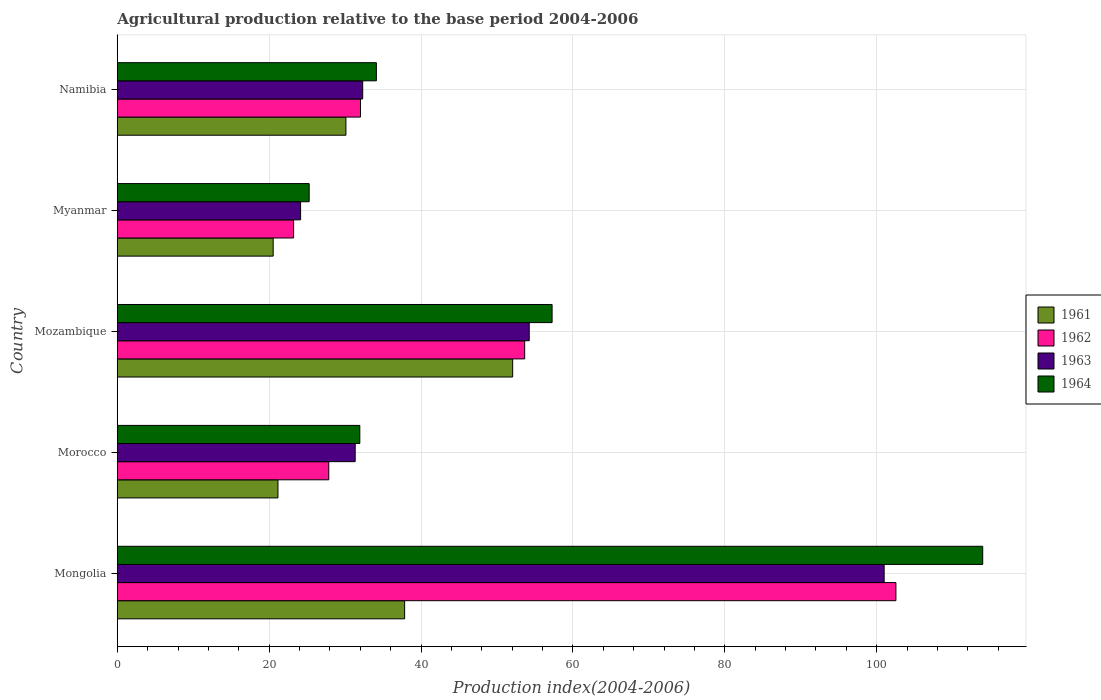How many groups of bars are there?
Offer a very short reply. 5. Are the number of bars per tick equal to the number of legend labels?
Offer a terse response. Yes. Are the number of bars on each tick of the Y-axis equal?
Offer a very short reply. Yes. How many bars are there on the 4th tick from the bottom?
Provide a short and direct response. 4. What is the label of the 3rd group of bars from the top?
Offer a terse response. Mozambique. In how many cases, is the number of bars for a given country not equal to the number of legend labels?
Provide a short and direct response. 0. What is the agricultural production index in 1962 in Morocco?
Ensure brevity in your answer.  27.85. Across all countries, what is the maximum agricultural production index in 1961?
Provide a short and direct response. 52.07. Across all countries, what is the minimum agricultural production index in 1962?
Ensure brevity in your answer.  23.22. In which country was the agricultural production index in 1963 maximum?
Provide a succinct answer. Mongolia. In which country was the agricultural production index in 1964 minimum?
Your response must be concise. Myanmar. What is the total agricultural production index in 1961 in the graph?
Give a very brief answer. 161.71. What is the difference between the agricultural production index in 1963 in Mongolia and that in Namibia?
Ensure brevity in your answer.  68.67. What is the difference between the agricultural production index in 1962 in Mozambique and the agricultural production index in 1964 in Morocco?
Your answer should be very brief. 21.71. What is the average agricultural production index in 1962 per country?
Your answer should be very brief. 47.86. What is the difference between the agricultural production index in 1962 and agricultural production index in 1964 in Mongolia?
Your answer should be compact. -11.43. In how many countries, is the agricultural production index in 1962 greater than 104 ?
Offer a very short reply. 0. What is the ratio of the agricultural production index in 1964 in Morocco to that in Myanmar?
Give a very brief answer. 1.26. Is the difference between the agricultural production index in 1962 in Mongolia and Myanmar greater than the difference between the agricultural production index in 1964 in Mongolia and Myanmar?
Make the answer very short. No. What is the difference between the highest and the second highest agricultural production index in 1964?
Your answer should be very brief. 56.71. What is the difference between the highest and the lowest agricultural production index in 1964?
Provide a short and direct response. 88.7. Is it the case that in every country, the sum of the agricultural production index in 1964 and agricultural production index in 1962 is greater than the sum of agricultural production index in 1961 and agricultural production index in 1963?
Your response must be concise. No. What does the 1st bar from the top in Myanmar represents?
Ensure brevity in your answer.  1964. What does the 3rd bar from the bottom in Mozambique represents?
Offer a very short reply. 1963. Is it the case that in every country, the sum of the agricultural production index in 1963 and agricultural production index in 1961 is greater than the agricultural production index in 1964?
Give a very brief answer. Yes. Are the values on the major ticks of X-axis written in scientific E-notation?
Provide a succinct answer. No. Does the graph contain grids?
Your answer should be compact. Yes. Where does the legend appear in the graph?
Provide a short and direct response. Center right. How are the legend labels stacked?
Your response must be concise. Vertical. What is the title of the graph?
Make the answer very short. Agricultural production relative to the base period 2004-2006. Does "2006" appear as one of the legend labels in the graph?
Give a very brief answer. No. What is the label or title of the X-axis?
Offer a terse response. Production index(2004-2006). What is the label or title of the Y-axis?
Make the answer very short. Country. What is the Production index(2004-2006) of 1961 in Mongolia?
Ensure brevity in your answer.  37.84. What is the Production index(2004-2006) of 1962 in Mongolia?
Ensure brevity in your answer.  102.54. What is the Production index(2004-2006) of 1963 in Mongolia?
Offer a terse response. 100.99. What is the Production index(2004-2006) in 1964 in Mongolia?
Your response must be concise. 113.97. What is the Production index(2004-2006) of 1961 in Morocco?
Make the answer very short. 21.16. What is the Production index(2004-2006) in 1962 in Morocco?
Your response must be concise. 27.85. What is the Production index(2004-2006) in 1963 in Morocco?
Make the answer very short. 31.33. What is the Production index(2004-2006) in 1964 in Morocco?
Make the answer very short. 31.94. What is the Production index(2004-2006) in 1961 in Mozambique?
Offer a terse response. 52.07. What is the Production index(2004-2006) in 1962 in Mozambique?
Your response must be concise. 53.65. What is the Production index(2004-2006) of 1963 in Mozambique?
Your answer should be compact. 54.25. What is the Production index(2004-2006) of 1964 in Mozambique?
Your answer should be compact. 57.26. What is the Production index(2004-2006) of 1961 in Myanmar?
Ensure brevity in your answer.  20.53. What is the Production index(2004-2006) in 1962 in Myanmar?
Ensure brevity in your answer.  23.22. What is the Production index(2004-2006) in 1963 in Myanmar?
Offer a terse response. 24.14. What is the Production index(2004-2006) in 1964 in Myanmar?
Keep it short and to the point. 25.27. What is the Production index(2004-2006) in 1961 in Namibia?
Your response must be concise. 30.11. What is the Production index(2004-2006) of 1962 in Namibia?
Give a very brief answer. 32.03. What is the Production index(2004-2006) of 1963 in Namibia?
Your response must be concise. 32.32. What is the Production index(2004-2006) of 1964 in Namibia?
Your answer should be very brief. 34.12. Across all countries, what is the maximum Production index(2004-2006) in 1961?
Your response must be concise. 52.07. Across all countries, what is the maximum Production index(2004-2006) in 1962?
Provide a succinct answer. 102.54. Across all countries, what is the maximum Production index(2004-2006) in 1963?
Ensure brevity in your answer.  100.99. Across all countries, what is the maximum Production index(2004-2006) of 1964?
Provide a succinct answer. 113.97. Across all countries, what is the minimum Production index(2004-2006) of 1961?
Offer a terse response. 20.53. Across all countries, what is the minimum Production index(2004-2006) in 1962?
Keep it short and to the point. 23.22. Across all countries, what is the minimum Production index(2004-2006) of 1963?
Offer a terse response. 24.14. Across all countries, what is the minimum Production index(2004-2006) in 1964?
Keep it short and to the point. 25.27. What is the total Production index(2004-2006) of 1961 in the graph?
Your answer should be compact. 161.71. What is the total Production index(2004-2006) in 1962 in the graph?
Provide a short and direct response. 239.29. What is the total Production index(2004-2006) in 1963 in the graph?
Keep it short and to the point. 243.03. What is the total Production index(2004-2006) in 1964 in the graph?
Provide a short and direct response. 262.56. What is the difference between the Production index(2004-2006) of 1961 in Mongolia and that in Morocco?
Offer a terse response. 16.68. What is the difference between the Production index(2004-2006) of 1962 in Mongolia and that in Morocco?
Offer a very short reply. 74.69. What is the difference between the Production index(2004-2006) in 1963 in Mongolia and that in Morocco?
Provide a succinct answer. 69.66. What is the difference between the Production index(2004-2006) in 1964 in Mongolia and that in Morocco?
Offer a terse response. 82.03. What is the difference between the Production index(2004-2006) in 1961 in Mongolia and that in Mozambique?
Offer a terse response. -14.23. What is the difference between the Production index(2004-2006) in 1962 in Mongolia and that in Mozambique?
Make the answer very short. 48.89. What is the difference between the Production index(2004-2006) of 1963 in Mongolia and that in Mozambique?
Provide a succinct answer. 46.74. What is the difference between the Production index(2004-2006) of 1964 in Mongolia and that in Mozambique?
Provide a succinct answer. 56.71. What is the difference between the Production index(2004-2006) in 1961 in Mongolia and that in Myanmar?
Give a very brief answer. 17.31. What is the difference between the Production index(2004-2006) of 1962 in Mongolia and that in Myanmar?
Keep it short and to the point. 79.32. What is the difference between the Production index(2004-2006) of 1963 in Mongolia and that in Myanmar?
Your answer should be compact. 76.85. What is the difference between the Production index(2004-2006) of 1964 in Mongolia and that in Myanmar?
Offer a terse response. 88.7. What is the difference between the Production index(2004-2006) of 1961 in Mongolia and that in Namibia?
Give a very brief answer. 7.73. What is the difference between the Production index(2004-2006) in 1962 in Mongolia and that in Namibia?
Your response must be concise. 70.51. What is the difference between the Production index(2004-2006) in 1963 in Mongolia and that in Namibia?
Your answer should be very brief. 68.67. What is the difference between the Production index(2004-2006) of 1964 in Mongolia and that in Namibia?
Make the answer very short. 79.85. What is the difference between the Production index(2004-2006) in 1961 in Morocco and that in Mozambique?
Keep it short and to the point. -30.91. What is the difference between the Production index(2004-2006) of 1962 in Morocco and that in Mozambique?
Offer a very short reply. -25.8. What is the difference between the Production index(2004-2006) of 1963 in Morocco and that in Mozambique?
Give a very brief answer. -22.92. What is the difference between the Production index(2004-2006) of 1964 in Morocco and that in Mozambique?
Your response must be concise. -25.32. What is the difference between the Production index(2004-2006) of 1961 in Morocco and that in Myanmar?
Provide a short and direct response. 0.63. What is the difference between the Production index(2004-2006) of 1962 in Morocco and that in Myanmar?
Provide a succinct answer. 4.63. What is the difference between the Production index(2004-2006) of 1963 in Morocco and that in Myanmar?
Offer a very short reply. 7.19. What is the difference between the Production index(2004-2006) in 1964 in Morocco and that in Myanmar?
Offer a terse response. 6.67. What is the difference between the Production index(2004-2006) in 1961 in Morocco and that in Namibia?
Your answer should be very brief. -8.95. What is the difference between the Production index(2004-2006) of 1962 in Morocco and that in Namibia?
Keep it short and to the point. -4.18. What is the difference between the Production index(2004-2006) of 1963 in Morocco and that in Namibia?
Offer a very short reply. -0.99. What is the difference between the Production index(2004-2006) of 1964 in Morocco and that in Namibia?
Your response must be concise. -2.18. What is the difference between the Production index(2004-2006) of 1961 in Mozambique and that in Myanmar?
Give a very brief answer. 31.54. What is the difference between the Production index(2004-2006) in 1962 in Mozambique and that in Myanmar?
Provide a short and direct response. 30.43. What is the difference between the Production index(2004-2006) in 1963 in Mozambique and that in Myanmar?
Ensure brevity in your answer.  30.11. What is the difference between the Production index(2004-2006) in 1964 in Mozambique and that in Myanmar?
Offer a very short reply. 31.99. What is the difference between the Production index(2004-2006) in 1961 in Mozambique and that in Namibia?
Your response must be concise. 21.96. What is the difference between the Production index(2004-2006) of 1962 in Mozambique and that in Namibia?
Your answer should be very brief. 21.62. What is the difference between the Production index(2004-2006) in 1963 in Mozambique and that in Namibia?
Offer a terse response. 21.93. What is the difference between the Production index(2004-2006) in 1964 in Mozambique and that in Namibia?
Make the answer very short. 23.14. What is the difference between the Production index(2004-2006) of 1961 in Myanmar and that in Namibia?
Make the answer very short. -9.58. What is the difference between the Production index(2004-2006) in 1962 in Myanmar and that in Namibia?
Offer a very short reply. -8.81. What is the difference between the Production index(2004-2006) of 1963 in Myanmar and that in Namibia?
Give a very brief answer. -8.18. What is the difference between the Production index(2004-2006) in 1964 in Myanmar and that in Namibia?
Offer a terse response. -8.85. What is the difference between the Production index(2004-2006) in 1961 in Mongolia and the Production index(2004-2006) in 1962 in Morocco?
Your answer should be compact. 9.99. What is the difference between the Production index(2004-2006) in 1961 in Mongolia and the Production index(2004-2006) in 1963 in Morocco?
Make the answer very short. 6.51. What is the difference between the Production index(2004-2006) of 1962 in Mongolia and the Production index(2004-2006) of 1963 in Morocco?
Provide a succinct answer. 71.21. What is the difference between the Production index(2004-2006) of 1962 in Mongolia and the Production index(2004-2006) of 1964 in Morocco?
Offer a terse response. 70.6. What is the difference between the Production index(2004-2006) of 1963 in Mongolia and the Production index(2004-2006) of 1964 in Morocco?
Provide a short and direct response. 69.05. What is the difference between the Production index(2004-2006) in 1961 in Mongolia and the Production index(2004-2006) in 1962 in Mozambique?
Provide a succinct answer. -15.81. What is the difference between the Production index(2004-2006) in 1961 in Mongolia and the Production index(2004-2006) in 1963 in Mozambique?
Give a very brief answer. -16.41. What is the difference between the Production index(2004-2006) in 1961 in Mongolia and the Production index(2004-2006) in 1964 in Mozambique?
Offer a terse response. -19.42. What is the difference between the Production index(2004-2006) of 1962 in Mongolia and the Production index(2004-2006) of 1963 in Mozambique?
Provide a short and direct response. 48.29. What is the difference between the Production index(2004-2006) in 1962 in Mongolia and the Production index(2004-2006) in 1964 in Mozambique?
Your response must be concise. 45.28. What is the difference between the Production index(2004-2006) of 1963 in Mongolia and the Production index(2004-2006) of 1964 in Mozambique?
Keep it short and to the point. 43.73. What is the difference between the Production index(2004-2006) in 1961 in Mongolia and the Production index(2004-2006) in 1962 in Myanmar?
Offer a very short reply. 14.62. What is the difference between the Production index(2004-2006) of 1961 in Mongolia and the Production index(2004-2006) of 1963 in Myanmar?
Offer a very short reply. 13.7. What is the difference between the Production index(2004-2006) of 1961 in Mongolia and the Production index(2004-2006) of 1964 in Myanmar?
Provide a short and direct response. 12.57. What is the difference between the Production index(2004-2006) in 1962 in Mongolia and the Production index(2004-2006) in 1963 in Myanmar?
Keep it short and to the point. 78.4. What is the difference between the Production index(2004-2006) in 1962 in Mongolia and the Production index(2004-2006) in 1964 in Myanmar?
Make the answer very short. 77.27. What is the difference between the Production index(2004-2006) in 1963 in Mongolia and the Production index(2004-2006) in 1964 in Myanmar?
Offer a very short reply. 75.72. What is the difference between the Production index(2004-2006) in 1961 in Mongolia and the Production index(2004-2006) in 1962 in Namibia?
Make the answer very short. 5.81. What is the difference between the Production index(2004-2006) of 1961 in Mongolia and the Production index(2004-2006) of 1963 in Namibia?
Your response must be concise. 5.52. What is the difference between the Production index(2004-2006) of 1961 in Mongolia and the Production index(2004-2006) of 1964 in Namibia?
Offer a terse response. 3.72. What is the difference between the Production index(2004-2006) of 1962 in Mongolia and the Production index(2004-2006) of 1963 in Namibia?
Your response must be concise. 70.22. What is the difference between the Production index(2004-2006) of 1962 in Mongolia and the Production index(2004-2006) of 1964 in Namibia?
Give a very brief answer. 68.42. What is the difference between the Production index(2004-2006) of 1963 in Mongolia and the Production index(2004-2006) of 1964 in Namibia?
Ensure brevity in your answer.  66.87. What is the difference between the Production index(2004-2006) in 1961 in Morocco and the Production index(2004-2006) in 1962 in Mozambique?
Make the answer very short. -32.49. What is the difference between the Production index(2004-2006) of 1961 in Morocco and the Production index(2004-2006) of 1963 in Mozambique?
Offer a terse response. -33.09. What is the difference between the Production index(2004-2006) of 1961 in Morocco and the Production index(2004-2006) of 1964 in Mozambique?
Provide a succinct answer. -36.1. What is the difference between the Production index(2004-2006) in 1962 in Morocco and the Production index(2004-2006) in 1963 in Mozambique?
Offer a terse response. -26.4. What is the difference between the Production index(2004-2006) in 1962 in Morocco and the Production index(2004-2006) in 1964 in Mozambique?
Keep it short and to the point. -29.41. What is the difference between the Production index(2004-2006) of 1963 in Morocco and the Production index(2004-2006) of 1964 in Mozambique?
Ensure brevity in your answer.  -25.93. What is the difference between the Production index(2004-2006) of 1961 in Morocco and the Production index(2004-2006) of 1962 in Myanmar?
Offer a terse response. -2.06. What is the difference between the Production index(2004-2006) of 1961 in Morocco and the Production index(2004-2006) of 1963 in Myanmar?
Offer a terse response. -2.98. What is the difference between the Production index(2004-2006) in 1961 in Morocco and the Production index(2004-2006) in 1964 in Myanmar?
Make the answer very short. -4.11. What is the difference between the Production index(2004-2006) of 1962 in Morocco and the Production index(2004-2006) of 1963 in Myanmar?
Make the answer very short. 3.71. What is the difference between the Production index(2004-2006) of 1962 in Morocco and the Production index(2004-2006) of 1964 in Myanmar?
Your answer should be compact. 2.58. What is the difference between the Production index(2004-2006) of 1963 in Morocco and the Production index(2004-2006) of 1964 in Myanmar?
Provide a short and direct response. 6.06. What is the difference between the Production index(2004-2006) in 1961 in Morocco and the Production index(2004-2006) in 1962 in Namibia?
Give a very brief answer. -10.87. What is the difference between the Production index(2004-2006) of 1961 in Morocco and the Production index(2004-2006) of 1963 in Namibia?
Offer a very short reply. -11.16. What is the difference between the Production index(2004-2006) of 1961 in Morocco and the Production index(2004-2006) of 1964 in Namibia?
Your answer should be very brief. -12.96. What is the difference between the Production index(2004-2006) in 1962 in Morocco and the Production index(2004-2006) in 1963 in Namibia?
Provide a succinct answer. -4.47. What is the difference between the Production index(2004-2006) in 1962 in Morocco and the Production index(2004-2006) in 1964 in Namibia?
Keep it short and to the point. -6.27. What is the difference between the Production index(2004-2006) of 1963 in Morocco and the Production index(2004-2006) of 1964 in Namibia?
Offer a very short reply. -2.79. What is the difference between the Production index(2004-2006) of 1961 in Mozambique and the Production index(2004-2006) of 1962 in Myanmar?
Keep it short and to the point. 28.85. What is the difference between the Production index(2004-2006) in 1961 in Mozambique and the Production index(2004-2006) in 1963 in Myanmar?
Give a very brief answer. 27.93. What is the difference between the Production index(2004-2006) of 1961 in Mozambique and the Production index(2004-2006) of 1964 in Myanmar?
Your answer should be compact. 26.8. What is the difference between the Production index(2004-2006) of 1962 in Mozambique and the Production index(2004-2006) of 1963 in Myanmar?
Offer a terse response. 29.51. What is the difference between the Production index(2004-2006) of 1962 in Mozambique and the Production index(2004-2006) of 1964 in Myanmar?
Make the answer very short. 28.38. What is the difference between the Production index(2004-2006) in 1963 in Mozambique and the Production index(2004-2006) in 1964 in Myanmar?
Offer a terse response. 28.98. What is the difference between the Production index(2004-2006) of 1961 in Mozambique and the Production index(2004-2006) of 1962 in Namibia?
Give a very brief answer. 20.04. What is the difference between the Production index(2004-2006) in 1961 in Mozambique and the Production index(2004-2006) in 1963 in Namibia?
Give a very brief answer. 19.75. What is the difference between the Production index(2004-2006) in 1961 in Mozambique and the Production index(2004-2006) in 1964 in Namibia?
Make the answer very short. 17.95. What is the difference between the Production index(2004-2006) in 1962 in Mozambique and the Production index(2004-2006) in 1963 in Namibia?
Give a very brief answer. 21.33. What is the difference between the Production index(2004-2006) in 1962 in Mozambique and the Production index(2004-2006) in 1964 in Namibia?
Keep it short and to the point. 19.53. What is the difference between the Production index(2004-2006) of 1963 in Mozambique and the Production index(2004-2006) of 1964 in Namibia?
Offer a very short reply. 20.13. What is the difference between the Production index(2004-2006) in 1961 in Myanmar and the Production index(2004-2006) in 1963 in Namibia?
Keep it short and to the point. -11.79. What is the difference between the Production index(2004-2006) in 1961 in Myanmar and the Production index(2004-2006) in 1964 in Namibia?
Ensure brevity in your answer.  -13.59. What is the difference between the Production index(2004-2006) in 1962 in Myanmar and the Production index(2004-2006) in 1963 in Namibia?
Give a very brief answer. -9.1. What is the difference between the Production index(2004-2006) of 1962 in Myanmar and the Production index(2004-2006) of 1964 in Namibia?
Provide a succinct answer. -10.9. What is the difference between the Production index(2004-2006) in 1963 in Myanmar and the Production index(2004-2006) in 1964 in Namibia?
Your answer should be compact. -9.98. What is the average Production index(2004-2006) of 1961 per country?
Give a very brief answer. 32.34. What is the average Production index(2004-2006) in 1962 per country?
Offer a very short reply. 47.86. What is the average Production index(2004-2006) in 1963 per country?
Offer a terse response. 48.61. What is the average Production index(2004-2006) of 1964 per country?
Offer a terse response. 52.51. What is the difference between the Production index(2004-2006) in 1961 and Production index(2004-2006) in 1962 in Mongolia?
Provide a short and direct response. -64.7. What is the difference between the Production index(2004-2006) of 1961 and Production index(2004-2006) of 1963 in Mongolia?
Provide a succinct answer. -63.15. What is the difference between the Production index(2004-2006) of 1961 and Production index(2004-2006) of 1964 in Mongolia?
Provide a short and direct response. -76.13. What is the difference between the Production index(2004-2006) of 1962 and Production index(2004-2006) of 1963 in Mongolia?
Provide a short and direct response. 1.55. What is the difference between the Production index(2004-2006) in 1962 and Production index(2004-2006) in 1964 in Mongolia?
Provide a succinct answer. -11.43. What is the difference between the Production index(2004-2006) in 1963 and Production index(2004-2006) in 1964 in Mongolia?
Your response must be concise. -12.98. What is the difference between the Production index(2004-2006) in 1961 and Production index(2004-2006) in 1962 in Morocco?
Your response must be concise. -6.69. What is the difference between the Production index(2004-2006) in 1961 and Production index(2004-2006) in 1963 in Morocco?
Give a very brief answer. -10.17. What is the difference between the Production index(2004-2006) of 1961 and Production index(2004-2006) of 1964 in Morocco?
Offer a very short reply. -10.78. What is the difference between the Production index(2004-2006) of 1962 and Production index(2004-2006) of 1963 in Morocco?
Your answer should be very brief. -3.48. What is the difference between the Production index(2004-2006) in 1962 and Production index(2004-2006) in 1964 in Morocco?
Provide a short and direct response. -4.09. What is the difference between the Production index(2004-2006) in 1963 and Production index(2004-2006) in 1964 in Morocco?
Offer a terse response. -0.61. What is the difference between the Production index(2004-2006) in 1961 and Production index(2004-2006) in 1962 in Mozambique?
Your answer should be compact. -1.58. What is the difference between the Production index(2004-2006) of 1961 and Production index(2004-2006) of 1963 in Mozambique?
Offer a terse response. -2.18. What is the difference between the Production index(2004-2006) of 1961 and Production index(2004-2006) of 1964 in Mozambique?
Provide a succinct answer. -5.19. What is the difference between the Production index(2004-2006) of 1962 and Production index(2004-2006) of 1964 in Mozambique?
Provide a succinct answer. -3.61. What is the difference between the Production index(2004-2006) of 1963 and Production index(2004-2006) of 1964 in Mozambique?
Make the answer very short. -3.01. What is the difference between the Production index(2004-2006) of 1961 and Production index(2004-2006) of 1962 in Myanmar?
Your response must be concise. -2.69. What is the difference between the Production index(2004-2006) in 1961 and Production index(2004-2006) in 1963 in Myanmar?
Provide a succinct answer. -3.61. What is the difference between the Production index(2004-2006) in 1961 and Production index(2004-2006) in 1964 in Myanmar?
Make the answer very short. -4.74. What is the difference between the Production index(2004-2006) in 1962 and Production index(2004-2006) in 1963 in Myanmar?
Your response must be concise. -0.92. What is the difference between the Production index(2004-2006) of 1962 and Production index(2004-2006) of 1964 in Myanmar?
Your response must be concise. -2.05. What is the difference between the Production index(2004-2006) of 1963 and Production index(2004-2006) of 1964 in Myanmar?
Make the answer very short. -1.13. What is the difference between the Production index(2004-2006) in 1961 and Production index(2004-2006) in 1962 in Namibia?
Offer a very short reply. -1.92. What is the difference between the Production index(2004-2006) in 1961 and Production index(2004-2006) in 1963 in Namibia?
Provide a short and direct response. -2.21. What is the difference between the Production index(2004-2006) in 1961 and Production index(2004-2006) in 1964 in Namibia?
Offer a terse response. -4.01. What is the difference between the Production index(2004-2006) of 1962 and Production index(2004-2006) of 1963 in Namibia?
Offer a very short reply. -0.29. What is the difference between the Production index(2004-2006) of 1962 and Production index(2004-2006) of 1964 in Namibia?
Offer a terse response. -2.09. What is the ratio of the Production index(2004-2006) in 1961 in Mongolia to that in Morocco?
Provide a short and direct response. 1.79. What is the ratio of the Production index(2004-2006) in 1962 in Mongolia to that in Morocco?
Ensure brevity in your answer.  3.68. What is the ratio of the Production index(2004-2006) of 1963 in Mongolia to that in Morocco?
Ensure brevity in your answer.  3.22. What is the ratio of the Production index(2004-2006) in 1964 in Mongolia to that in Morocco?
Keep it short and to the point. 3.57. What is the ratio of the Production index(2004-2006) of 1961 in Mongolia to that in Mozambique?
Your response must be concise. 0.73. What is the ratio of the Production index(2004-2006) of 1962 in Mongolia to that in Mozambique?
Offer a very short reply. 1.91. What is the ratio of the Production index(2004-2006) in 1963 in Mongolia to that in Mozambique?
Make the answer very short. 1.86. What is the ratio of the Production index(2004-2006) in 1964 in Mongolia to that in Mozambique?
Your response must be concise. 1.99. What is the ratio of the Production index(2004-2006) in 1961 in Mongolia to that in Myanmar?
Give a very brief answer. 1.84. What is the ratio of the Production index(2004-2006) in 1962 in Mongolia to that in Myanmar?
Your answer should be very brief. 4.42. What is the ratio of the Production index(2004-2006) in 1963 in Mongolia to that in Myanmar?
Offer a very short reply. 4.18. What is the ratio of the Production index(2004-2006) of 1964 in Mongolia to that in Myanmar?
Offer a very short reply. 4.51. What is the ratio of the Production index(2004-2006) of 1961 in Mongolia to that in Namibia?
Your answer should be compact. 1.26. What is the ratio of the Production index(2004-2006) of 1962 in Mongolia to that in Namibia?
Make the answer very short. 3.2. What is the ratio of the Production index(2004-2006) in 1963 in Mongolia to that in Namibia?
Provide a succinct answer. 3.12. What is the ratio of the Production index(2004-2006) of 1964 in Mongolia to that in Namibia?
Provide a succinct answer. 3.34. What is the ratio of the Production index(2004-2006) in 1961 in Morocco to that in Mozambique?
Keep it short and to the point. 0.41. What is the ratio of the Production index(2004-2006) of 1962 in Morocco to that in Mozambique?
Your answer should be very brief. 0.52. What is the ratio of the Production index(2004-2006) in 1963 in Morocco to that in Mozambique?
Offer a terse response. 0.58. What is the ratio of the Production index(2004-2006) in 1964 in Morocco to that in Mozambique?
Your response must be concise. 0.56. What is the ratio of the Production index(2004-2006) of 1961 in Morocco to that in Myanmar?
Give a very brief answer. 1.03. What is the ratio of the Production index(2004-2006) in 1962 in Morocco to that in Myanmar?
Keep it short and to the point. 1.2. What is the ratio of the Production index(2004-2006) of 1963 in Morocco to that in Myanmar?
Your response must be concise. 1.3. What is the ratio of the Production index(2004-2006) in 1964 in Morocco to that in Myanmar?
Your answer should be compact. 1.26. What is the ratio of the Production index(2004-2006) in 1961 in Morocco to that in Namibia?
Give a very brief answer. 0.7. What is the ratio of the Production index(2004-2006) of 1962 in Morocco to that in Namibia?
Offer a very short reply. 0.87. What is the ratio of the Production index(2004-2006) of 1963 in Morocco to that in Namibia?
Provide a succinct answer. 0.97. What is the ratio of the Production index(2004-2006) in 1964 in Morocco to that in Namibia?
Provide a short and direct response. 0.94. What is the ratio of the Production index(2004-2006) in 1961 in Mozambique to that in Myanmar?
Make the answer very short. 2.54. What is the ratio of the Production index(2004-2006) of 1962 in Mozambique to that in Myanmar?
Your answer should be very brief. 2.31. What is the ratio of the Production index(2004-2006) in 1963 in Mozambique to that in Myanmar?
Your answer should be very brief. 2.25. What is the ratio of the Production index(2004-2006) of 1964 in Mozambique to that in Myanmar?
Offer a terse response. 2.27. What is the ratio of the Production index(2004-2006) in 1961 in Mozambique to that in Namibia?
Your answer should be very brief. 1.73. What is the ratio of the Production index(2004-2006) of 1962 in Mozambique to that in Namibia?
Ensure brevity in your answer.  1.68. What is the ratio of the Production index(2004-2006) of 1963 in Mozambique to that in Namibia?
Your response must be concise. 1.68. What is the ratio of the Production index(2004-2006) in 1964 in Mozambique to that in Namibia?
Keep it short and to the point. 1.68. What is the ratio of the Production index(2004-2006) in 1961 in Myanmar to that in Namibia?
Keep it short and to the point. 0.68. What is the ratio of the Production index(2004-2006) of 1962 in Myanmar to that in Namibia?
Keep it short and to the point. 0.72. What is the ratio of the Production index(2004-2006) in 1963 in Myanmar to that in Namibia?
Your answer should be compact. 0.75. What is the ratio of the Production index(2004-2006) of 1964 in Myanmar to that in Namibia?
Make the answer very short. 0.74. What is the difference between the highest and the second highest Production index(2004-2006) of 1961?
Offer a terse response. 14.23. What is the difference between the highest and the second highest Production index(2004-2006) of 1962?
Provide a succinct answer. 48.89. What is the difference between the highest and the second highest Production index(2004-2006) of 1963?
Make the answer very short. 46.74. What is the difference between the highest and the second highest Production index(2004-2006) of 1964?
Offer a terse response. 56.71. What is the difference between the highest and the lowest Production index(2004-2006) in 1961?
Your response must be concise. 31.54. What is the difference between the highest and the lowest Production index(2004-2006) of 1962?
Offer a terse response. 79.32. What is the difference between the highest and the lowest Production index(2004-2006) in 1963?
Make the answer very short. 76.85. What is the difference between the highest and the lowest Production index(2004-2006) of 1964?
Provide a succinct answer. 88.7. 